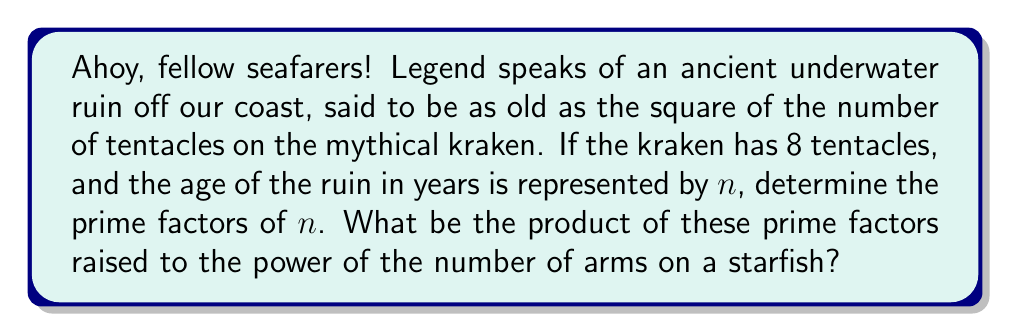Teach me how to tackle this problem. Let's approach this problem step by step:

1) First, we need to calculate the age of the ruin:
   - The kraken has 8 tentacles
   - The age is the square of this number
   - So, $n = 8^2 = 64$ years

2) Now, we need to find the prime factors of 64:
   $$64 = 2^6$$
   
   We can see this by continually dividing by 2:
   $$64 \div 2 = 32$$
   $$32 \div 2 = 16$$
   $$16 \div 2 = 8$$
   $$8 \div 2 = 4$$
   $$4 \div 2 = 2$$
   $$2 \div 2 = 1$$

3) So, the only prime factor of 64 is 2, and it appears 6 times.

4) The question asks for the product of these prime factors raised to the power of the number of arms on a starfish. A typical starfish has 5 arms.

5) Therefore, we need to calculate:
   $$(2^6)^5 = 2^{30}$$

6) We can calculate this:
   $$2^{30} = 1,073,741,824$$
Answer: $1,073,741,824$ 